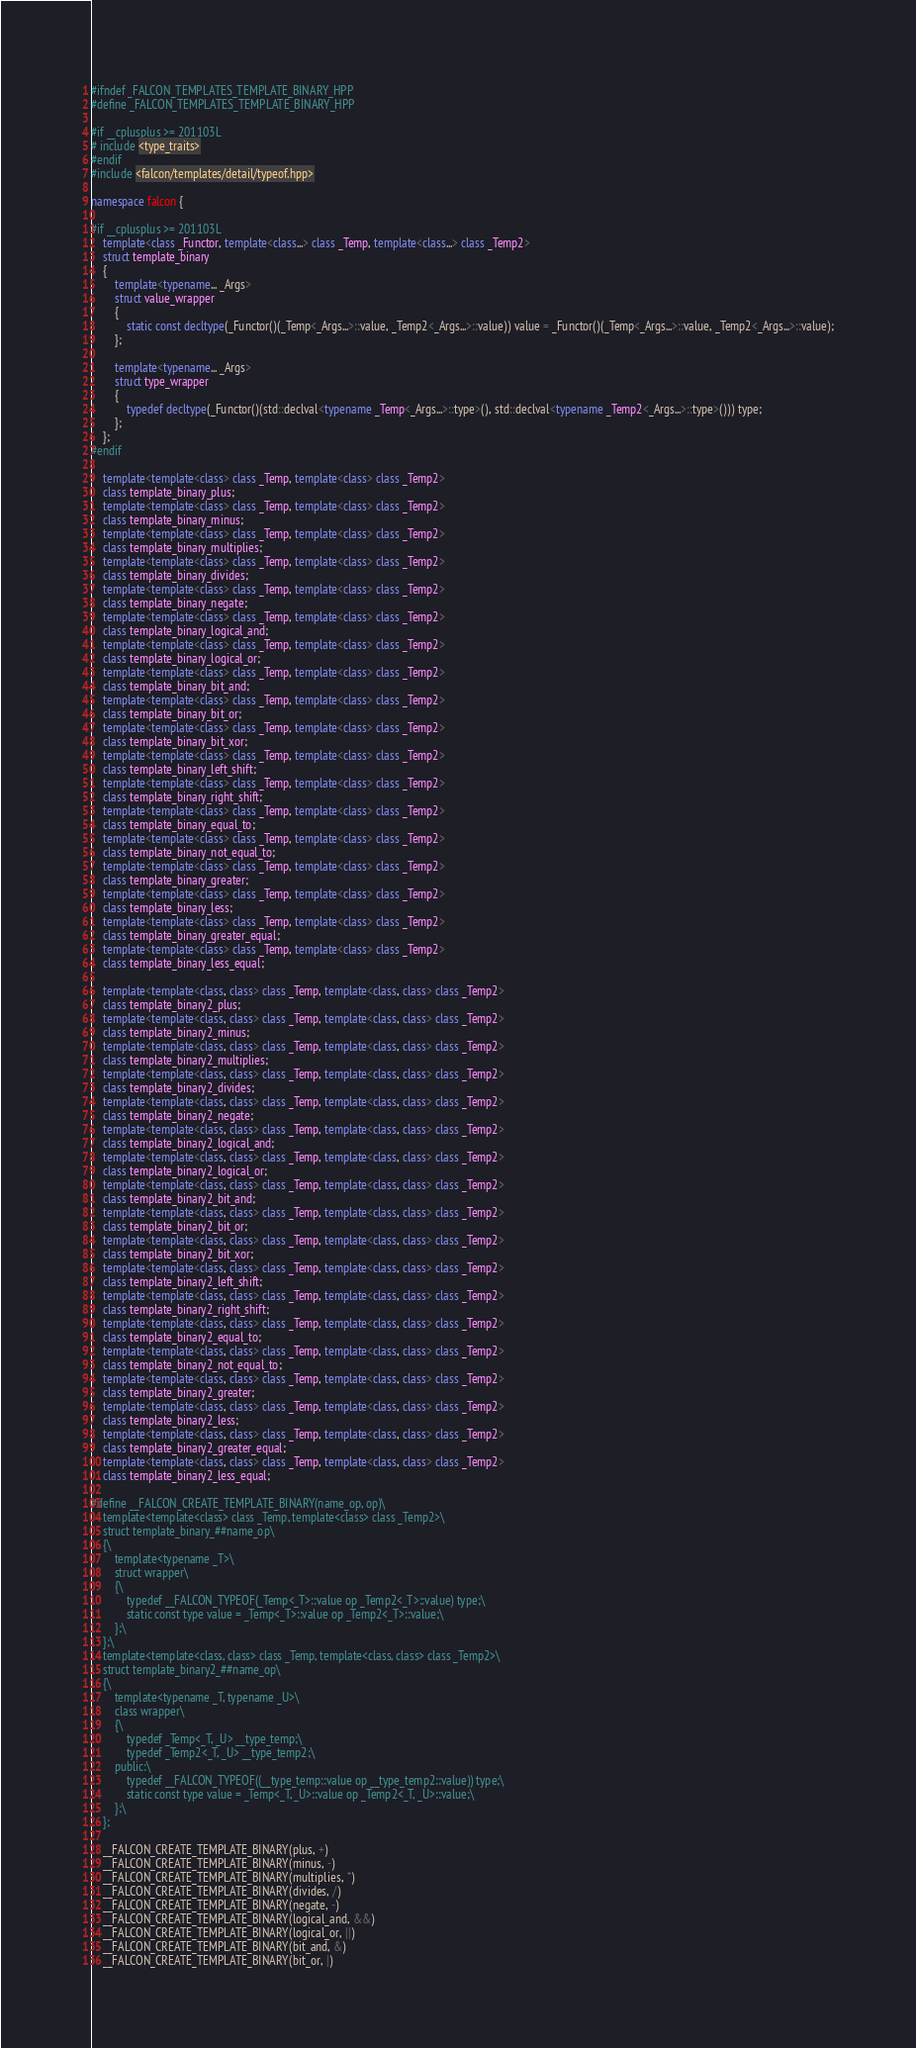Convert code to text. <code><loc_0><loc_0><loc_500><loc_500><_C++_>#ifndef _FALCON_TEMPLATES_TEMPLATE_BINARY_HPP
#define _FALCON_TEMPLATES_TEMPLATE_BINARY_HPP

#if __cplusplus >= 201103L
# include <type_traits>
#endif
#include <falcon/templates/detail/typeof.hpp>

namespace falcon {

#if __cplusplus >= 201103L
	template<class _Functor, template<class...> class _Temp, template<class...> class _Temp2>
	struct template_binary
	{
		template<typename... _Args>
		struct value_wrapper
		{
			static const decltype(_Functor()(_Temp<_Args...>::value, _Temp2<_Args...>::value)) value = _Functor()(_Temp<_Args...>::value, _Temp2<_Args...>::value);
		};

		template<typename... _Args>
		struct type_wrapper
		{
			typedef decltype(_Functor()(std::declval<typename _Temp<_Args...>::type>(), std::declval<typename _Temp2<_Args...>::type>())) type;
		};
	};
#endif

	template<template<class> class _Temp, template<class> class _Temp2>
	class template_binary_plus;
	template<template<class> class _Temp, template<class> class _Temp2>
	class template_binary_minus;
	template<template<class> class _Temp, template<class> class _Temp2>
	class template_binary_multiplies;
	template<template<class> class _Temp, template<class> class _Temp2>
	class template_binary_divides;
	template<template<class> class _Temp, template<class> class _Temp2>
	class template_binary_negate;
	template<template<class> class _Temp, template<class> class _Temp2>
	class template_binary_logical_and;
	template<template<class> class _Temp, template<class> class _Temp2>
	class template_binary_logical_or;
	template<template<class> class _Temp, template<class> class _Temp2>
	class template_binary_bit_and;
	template<template<class> class _Temp, template<class> class _Temp2>
	class template_binary_bit_or;
	template<template<class> class _Temp, template<class> class _Temp2>
	class template_binary_bit_xor;
	template<template<class> class _Temp, template<class> class _Temp2>
	class template_binary_left_shift;
	template<template<class> class _Temp, template<class> class _Temp2>
	class template_binary_right_shift;
	template<template<class> class _Temp, template<class> class _Temp2>
	class template_binary_equal_to;
	template<template<class> class _Temp, template<class> class _Temp2>
	class template_binary_not_equal_to;
	template<template<class> class _Temp, template<class> class _Temp2>
	class template_binary_greater;
	template<template<class> class _Temp, template<class> class _Temp2>
	class template_binary_less;
	template<template<class> class _Temp, template<class> class _Temp2>
	class template_binary_greater_equal;
	template<template<class> class _Temp, template<class> class _Temp2>
	class template_binary_less_equal;

	template<template<class, class> class _Temp, template<class, class> class _Temp2>
	class template_binary2_plus;
	template<template<class, class> class _Temp, template<class, class> class _Temp2>
	class template_binary2_minus;
	template<template<class, class> class _Temp, template<class, class> class _Temp2>
	class template_binary2_multiplies;
	template<template<class, class> class _Temp, template<class, class> class _Temp2>
	class template_binary2_divides;
	template<template<class, class> class _Temp, template<class, class> class _Temp2>
	class template_binary2_negate;
	template<template<class, class> class _Temp, template<class, class> class _Temp2>
	class template_binary2_logical_and;
	template<template<class, class> class _Temp, template<class, class> class _Temp2>
	class template_binary2_logical_or;
	template<template<class, class> class _Temp, template<class, class> class _Temp2>
	class template_binary2_bit_and;
	template<template<class, class> class _Temp, template<class, class> class _Temp2>
	class template_binary2_bit_or;
	template<template<class, class> class _Temp, template<class, class> class _Temp2>
	class template_binary2_bit_xor;
	template<template<class, class> class _Temp, template<class, class> class _Temp2>
	class template_binary2_left_shift;
	template<template<class, class> class _Temp, template<class, class> class _Temp2>
	class template_binary2_right_shift;
	template<template<class, class> class _Temp, template<class, class> class _Temp2>
	class template_binary2_equal_to;
	template<template<class, class> class _Temp, template<class, class> class _Temp2>
	class template_binary2_not_equal_to;
	template<template<class, class> class _Temp, template<class, class> class _Temp2>
	class template_binary2_greater;
	template<template<class, class> class _Temp, template<class, class> class _Temp2>
	class template_binary2_less;
	template<template<class, class> class _Temp, template<class, class> class _Temp2>
	class template_binary2_greater_equal;
	template<template<class, class> class _Temp, template<class, class> class _Temp2>
	class template_binary2_less_equal;

#define __FALCON_CREATE_TEMPLATE_BINARY(name_op, op)\
	template<template<class> class _Temp, template<class> class _Temp2>\
	struct template_binary_##name_op\
	{\
		template<typename _T>\
		struct wrapper\
		{\
			typedef __FALCON_TYPEOF(_Temp<_T>::value op _Temp2<_T>::value) type;\
			static const type value = _Temp<_T>::value op _Temp2<_T>::value;\
		};\
	};\
	template<template<class, class> class _Temp, template<class, class> class _Temp2>\
	struct template_binary2_##name_op\
	{\
		template<typename _T, typename _U>\
		class wrapper\
		{\
			typedef _Temp<_T, _U> __type_temp;\
			typedef _Temp2<_T, _U> __type_temp2;\
		public:\
			typedef __FALCON_TYPEOF((__type_temp::value op __type_temp2::value)) type;\
			static const type value = _Temp<_T, _U>::value op _Temp2<_T, _U>::value;\
		};\
	};

	__FALCON_CREATE_TEMPLATE_BINARY(plus, +)
	__FALCON_CREATE_TEMPLATE_BINARY(minus, -)
	__FALCON_CREATE_TEMPLATE_BINARY(multiplies, *)
	__FALCON_CREATE_TEMPLATE_BINARY(divides, /)
	__FALCON_CREATE_TEMPLATE_BINARY(negate, -)
	__FALCON_CREATE_TEMPLATE_BINARY(logical_and, &&)
	__FALCON_CREATE_TEMPLATE_BINARY(logical_or, ||)
	__FALCON_CREATE_TEMPLATE_BINARY(bit_and, &)
	__FALCON_CREATE_TEMPLATE_BINARY(bit_or, |)</code> 